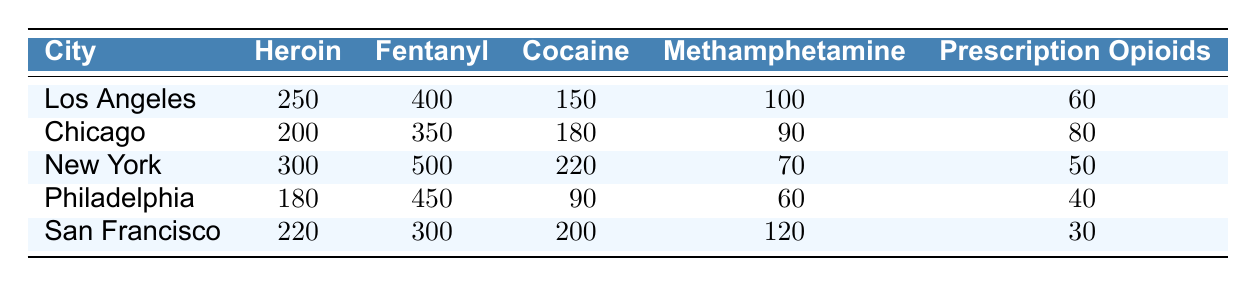What's the total number of reported Fentanyl overdoses in Los Angeles? The table shows that Los Angeles has 400 reported overdoses specifically for Fentanyl. This number is explicitly stated in the table under the Fentanyl column for the Los Angeles row.
Answer: 400 Which city reported the highest number of Cocaine overdoses? By looking at the Cocaine column across the cities, we find that New York has 220 reported overdoses, which is higher than the values of other cities: Los Angeles (150), Chicago (180), Philadelphia (90), and San Francisco (200).
Answer: New York What is the average number of Heroin overdoses across all cities? To find the average, we sum the Heroin overdoses: 250 (Los Angeles) + 200 (Chicago) + 300 (New York) + 180 (Philadelphia) + 220 (San Francisco) = 1150. There are 5 cities, so the average is 1150 / 5 = 230.
Answer: 230 Are there more reported Methamphetamine overdoses in San Francisco than in Chicago? San Francisco reports 120 Methamphetamine overdoses, while Chicago reports 90. Comparing the two values clearly shows that San Francisco's count is indeed higher.
Answer: Yes What is the total number of overdoses reported for Prescription Opioids in Chicago and Philadelphia combined? In Chicago, there are 80 reported overdoses, and in Philadelphia, there are 40. To find the combined total, we add these two values: 80 + 40 = 120.
Answer: 120 Which substance had the lowest number of reported overdoses in New York? From the New York row, we see Heroin (300), Fentanyl (500), Cocaine (220), Methamphetamine (70), and Prescription Opioids (50). The lowest among these is Prescription Opioids, which has 50 overdoses.
Answer: Prescription Opioids If we consider the total number of overdoses for all substances in Philadelphia, what is the result? Adding the reported overdoses for Philadelphia gives us: 180 (Heroin) + 450 (Fentanyl) + 90 (Cocaine) + 60 (Methamphetamine) + 40 (Prescription Opioids) = 820. Therefore, the total is 820.
Answer: 820 Is it true that more than half of the reported overdoses in San Francisco were due to Fentanyl? In San Francisco, the total number of overdoses (sum of all types) is 220 (Heroin) + 300 (Fentanyl) + 200 (Cocaine) + 120 (Methamphetamine) + 30 (Prescription Opioids) = 870. The Fentanyl overdoses are 300. To find if it's more than half, we check if 300 > 870 / 2 (which is 435). Since 300 is less than 435, the statement is false.
Answer: No What is the difference between the highest and lowest number of reported overdoses for Methamphetamine across the cities? The highest number of Methamphetamine overdoses is in San Francisco with 120, while the lowest is in New York with 70. The difference is 120 - 70 = 50.
Answer: 50 